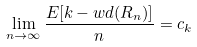<formula> <loc_0><loc_0><loc_500><loc_500>\lim _ { n \rightarrow \infty } \frac { E [ k - w d ( R _ { n } ) ] } { n } = c _ { k }</formula> 